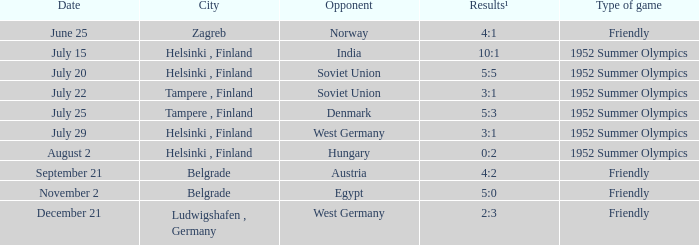With the Type is game of friendly and the City Belgrade and November 2 as the Date what were the Results¹? 5:0. 